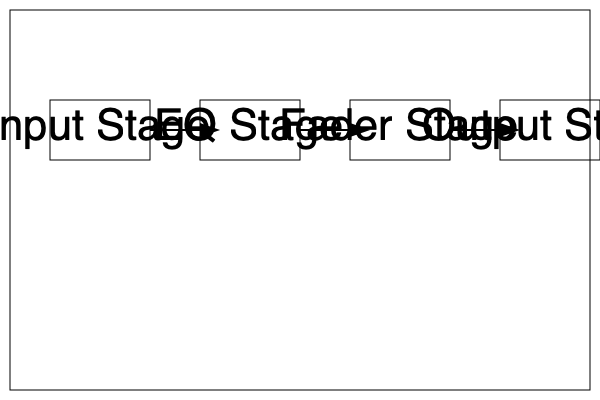As a music producer working on the next big emo anthem, you're setting up your mixing console. Looking at the block diagram of a basic mixing console, what is the correct order of signal flow? Let's break down the signal flow in a basic mixing console using the block diagram:

1. Input Stage: This is where the audio signal enters the console. It typically includes a preamp to boost the signal to line level and may have a gain control.

2. EQ Stage: After the input, the signal passes through the equalization (EQ) section. This allows you to adjust the frequency balance of the sound, which is crucial for shaping the tone of instruments in your mix.

3. Fader Stage: Following the EQ, the signal reaches the fader. This stage controls the volume level of the individual channel. It's where you set the relative levels of different instruments in your mix.

4. Output Stage: Finally, the signal reaches the output stage. This is where the processed and level-adjusted signal is sent to the main mix bus or to other destinations like aux sends or subgroups.

The diagram clearly shows this flow from left to right: Input Stage → EQ Stage → Fader Stage → Output Stage. This order is standard in most mixing consoles and allows for logical processing of the audio signal.

Understanding this signal flow is essential for effectively using a mixing console, whether you're recording a live My Chemical Romance-inspired performance or mixing tracks in the studio.
Answer: Input → EQ → Fader → Output 